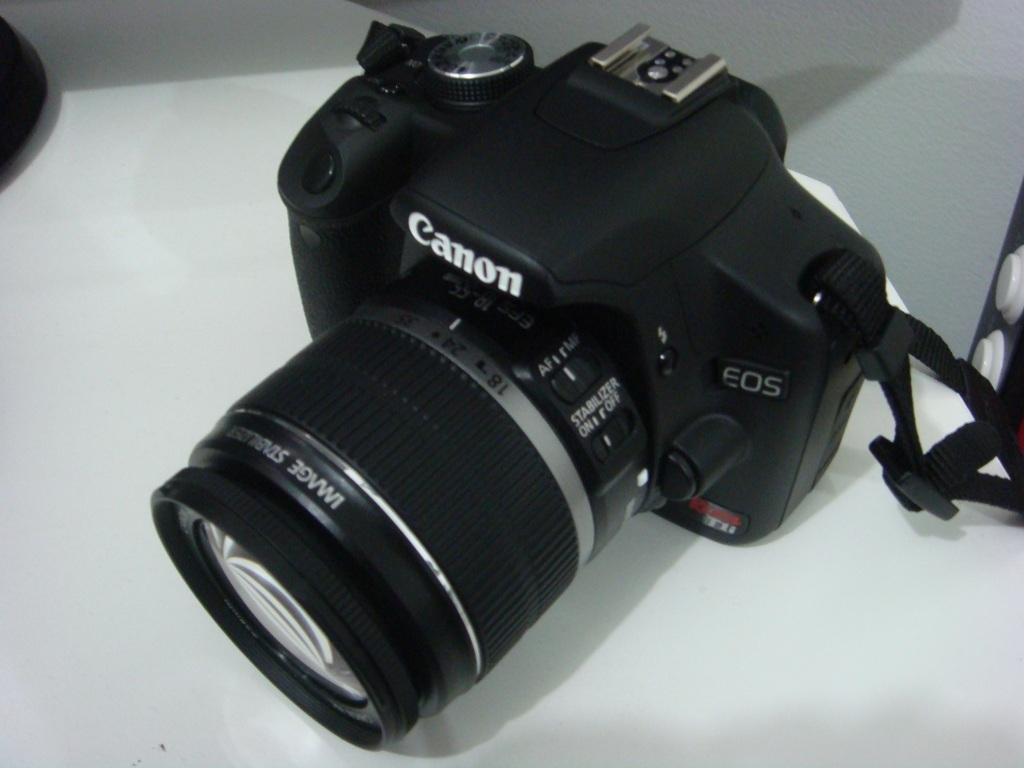What object is the main subject of the image? There is a camera in the image. What is the color of the camera? The camera is black in color. Are there any markings or text on the camera? Yes, there are words written on the camera. What is the camera placed on in the image? The camera is on a white surface. Can you see the camera kicking a soccer ball in the image? No, there is no soccer ball or any indication of the camera kicking in the image. 